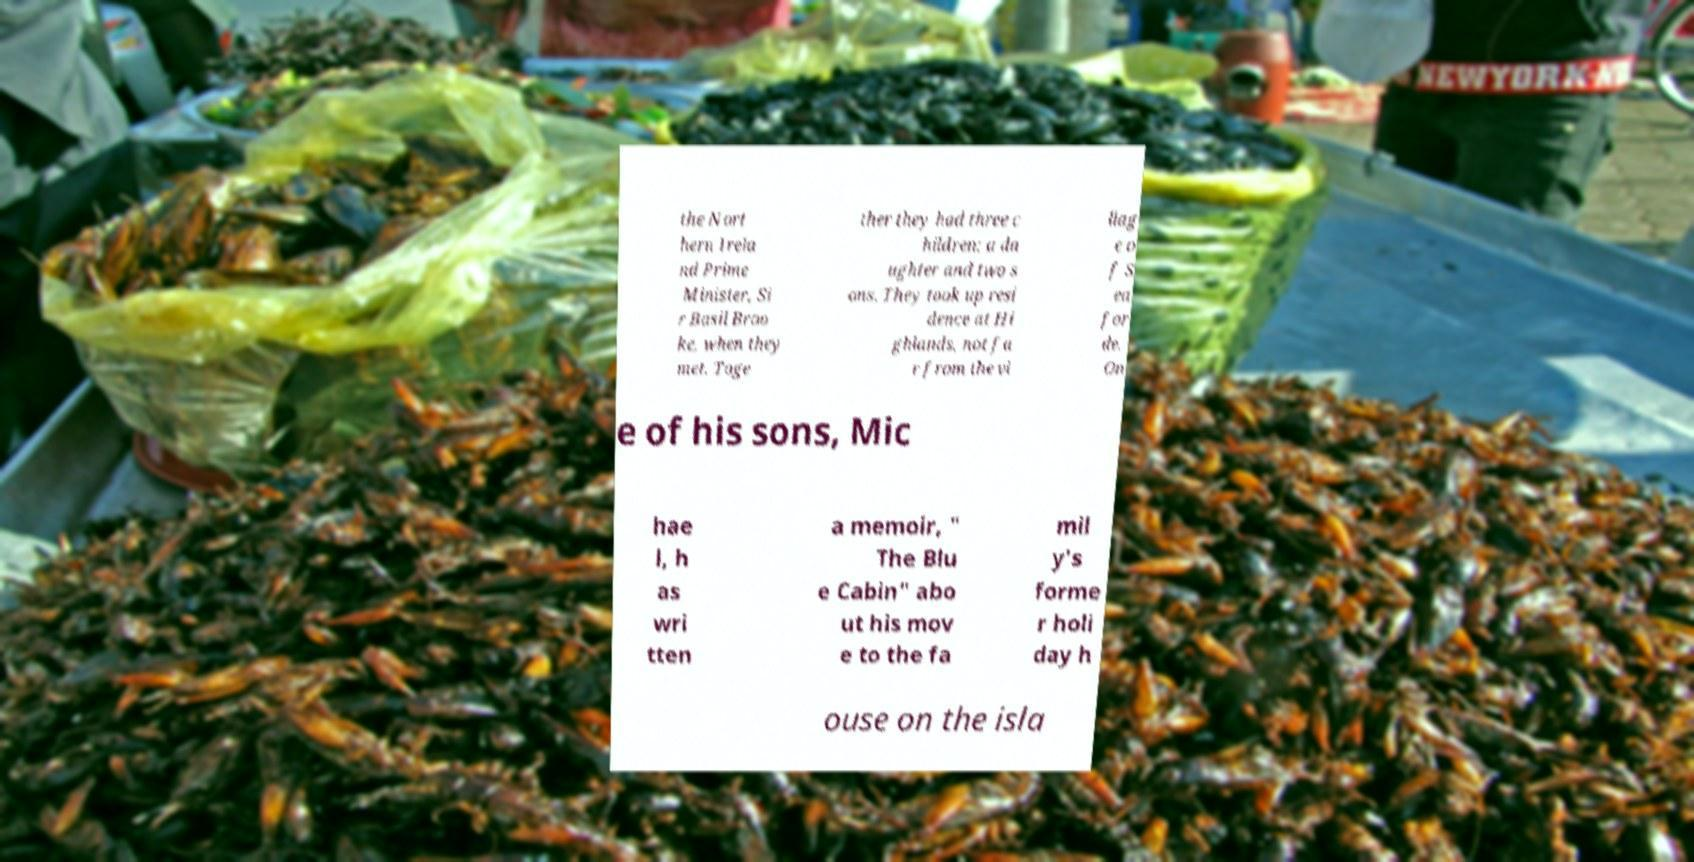Could you extract and type out the text from this image? the Nort hern Irela nd Prime Minister, Si r Basil Broo ke, when they met. Toge ther they had three c hildren: a da ughter and two s ons. They took up resi dence at Hi ghlands, not fa r from the vi llag e o f S ea for de. On e of his sons, Mic hae l, h as wri tten a memoir, " The Blu e Cabin" abo ut his mov e to the fa mil y's forme r holi day h ouse on the isla 